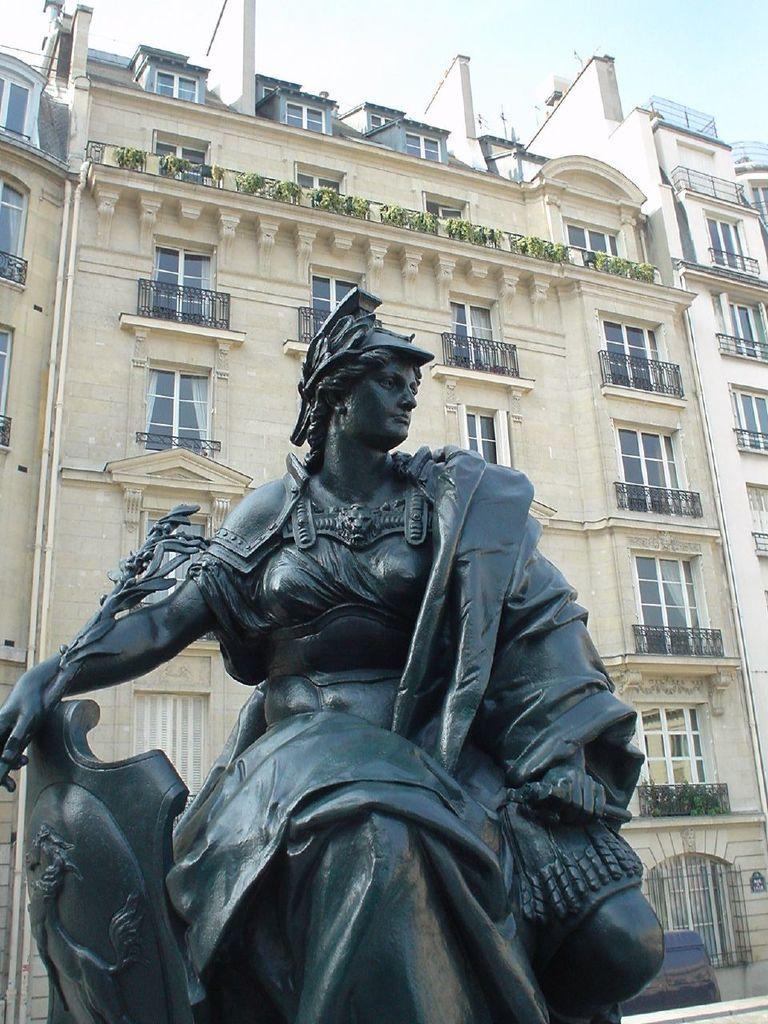How would you summarize this image in a sentence or two? In the picture we can see a sculpture of a person which is black in color and behind it, we can see a building with many windows and to it we can see railings and on the top of the building we can see a part of the sky. 